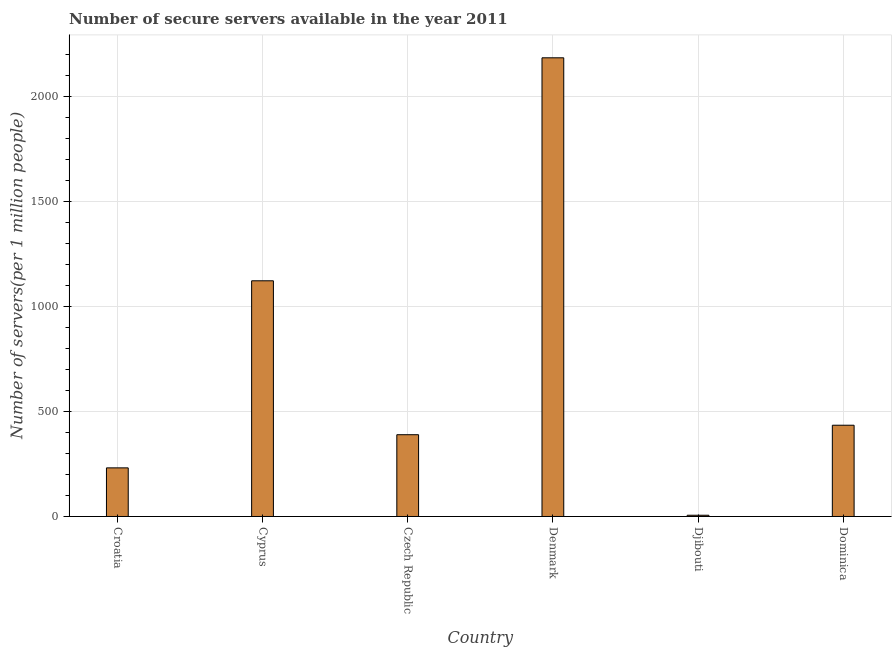What is the title of the graph?
Provide a short and direct response. Number of secure servers available in the year 2011. What is the label or title of the Y-axis?
Provide a short and direct response. Number of servers(per 1 million people). What is the number of secure internet servers in Croatia?
Give a very brief answer. 231.27. Across all countries, what is the maximum number of secure internet servers?
Keep it short and to the point. 2182. Across all countries, what is the minimum number of secure internet servers?
Give a very brief answer. 5.94. In which country was the number of secure internet servers minimum?
Offer a terse response. Djibouti. What is the sum of the number of secure internet servers?
Make the answer very short. 4363.6. What is the difference between the number of secure internet servers in Croatia and Denmark?
Offer a very short reply. -1950.73. What is the average number of secure internet servers per country?
Your response must be concise. 727.27. What is the median number of secure internet servers?
Offer a terse response. 411.58. In how many countries, is the number of secure internet servers greater than 800 ?
Provide a short and direct response. 2. What is the ratio of the number of secure internet servers in Denmark to that in Djibouti?
Your answer should be very brief. 367.36. Is the number of secure internet servers in Croatia less than that in Denmark?
Your response must be concise. Yes. What is the difference between the highest and the second highest number of secure internet servers?
Ensure brevity in your answer.  1060.79. Is the sum of the number of secure internet servers in Cyprus and Denmark greater than the maximum number of secure internet servers across all countries?
Your answer should be very brief. Yes. What is the difference between the highest and the lowest number of secure internet servers?
Give a very brief answer. 2176.06. Are all the bars in the graph horizontal?
Make the answer very short. No. How many countries are there in the graph?
Offer a terse response. 6. What is the difference between two consecutive major ticks on the Y-axis?
Offer a terse response. 500. Are the values on the major ticks of Y-axis written in scientific E-notation?
Your answer should be compact. No. What is the Number of servers(per 1 million people) of Croatia?
Give a very brief answer. 231.27. What is the Number of servers(per 1 million people) of Cyprus?
Ensure brevity in your answer.  1121.22. What is the Number of servers(per 1 million people) in Czech Republic?
Your response must be concise. 389. What is the Number of servers(per 1 million people) in Denmark?
Offer a terse response. 2182. What is the Number of servers(per 1 million people) in Djibouti?
Offer a very short reply. 5.94. What is the Number of servers(per 1 million people) of Dominica?
Your answer should be compact. 434.16. What is the difference between the Number of servers(per 1 million people) in Croatia and Cyprus?
Offer a very short reply. -889.94. What is the difference between the Number of servers(per 1 million people) in Croatia and Czech Republic?
Your response must be concise. -157.73. What is the difference between the Number of servers(per 1 million people) in Croatia and Denmark?
Give a very brief answer. -1950.73. What is the difference between the Number of servers(per 1 million people) in Croatia and Djibouti?
Ensure brevity in your answer.  225.34. What is the difference between the Number of servers(per 1 million people) in Croatia and Dominica?
Your answer should be compact. -202.89. What is the difference between the Number of servers(per 1 million people) in Cyprus and Czech Republic?
Your response must be concise. 732.21. What is the difference between the Number of servers(per 1 million people) in Cyprus and Denmark?
Offer a very short reply. -1060.79. What is the difference between the Number of servers(per 1 million people) in Cyprus and Djibouti?
Offer a terse response. 1115.28. What is the difference between the Number of servers(per 1 million people) in Cyprus and Dominica?
Offer a terse response. 687.06. What is the difference between the Number of servers(per 1 million people) in Czech Republic and Denmark?
Your answer should be very brief. -1793. What is the difference between the Number of servers(per 1 million people) in Czech Republic and Djibouti?
Offer a terse response. 383.06. What is the difference between the Number of servers(per 1 million people) in Czech Republic and Dominica?
Offer a very short reply. -45.16. What is the difference between the Number of servers(per 1 million people) in Denmark and Djibouti?
Provide a short and direct response. 2176.06. What is the difference between the Number of servers(per 1 million people) in Denmark and Dominica?
Offer a very short reply. 1747.84. What is the difference between the Number of servers(per 1 million people) in Djibouti and Dominica?
Offer a terse response. -428.22. What is the ratio of the Number of servers(per 1 million people) in Croatia to that in Cyprus?
Ensure brevity in your answer.  0.21. What is the ratio of the Number of servers(per 1 million people) in Croatia to that in Czech Republic?
Offer a terse response. 0.59. What is the ratio of the Number of servers(per 1 million people) in Croatia to that in Denmark?
Provide a succinct answer. 0.11. What is the ratio of the Number of servers(per 1 million people) in Croatia to that in Djibouti?
Offer a terse response. 38.94. What is the ratio of the Number of servers(per 1 million people) in Croatia to that in Dominica?
Give a very brief answer. 0.53. What is the ratio of the Number of servers(per 1 million people) in Cyprus to that in Czech Republic?
Your answer should be compact. 2.88. What is the ratio of the Number of servers(per 1 million people) in Cyprus to that in Denmark?
Make the answer very short. 0.51. What is the ratio of the Number of servers(per 1 million people) in Cyprus to that in Djibouti?
Provide a short and direct response. 188.77. What is the ratio of the Number of servers(per 1 million people) in Cyprus to that in Dominica?
Make the answer very short. 2.58. What is the ratio of the Number of servers(per 1 million people) in Czech Republic to that in Denmark?
Your answer should be compact. 0.18. What is the ratio of the Number of servers(per 1 million people) in Czech Republic to that in Djibouti?
Your answer should be compact. 65.49. What is the ratio of the Number of servers(per 1 million people) in Czech Republic to that in Dominica?
Offer a very short reply. 0.9. What is the ratio of the Number of servers(per 1 million people) in Denmark to that in Djibouti?
Ensure brevity in your answer.  367.36. What is the ratio of the Number of servers(per 1 million people) in Denmark to that in Dominica?
Your answer should be compact. 5.03. What is the ratio of the Number of servers(per 1 million people) in Djibouti to that in Dominica?
Ensure brevity in your answer.  0.01. 